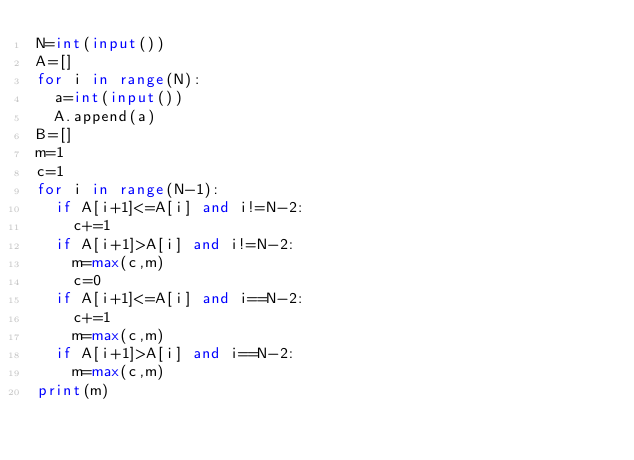Convert code to text. <code><loc_0><loc_0><loc_500><loc_500><_Python_>N=int(input())
A=[]
for i in range(N):
  a=int(input())
  A.append(a)
B=[]
m=1
c=1
for i in range(N-1):
  if A[i+1]<=A[i] and i!=N-2:
    c+=1
  if A[i+1]>A[i] and i!=N-2:
    m=max(c,m)
    c=0
  if A[i+1]<=A[i] and i==N-2:
    c+=1
    m=max(c,m)
  if A[i+1]>A[i] and i==N-2:
    m=max(c,m)
print(m)</code> 